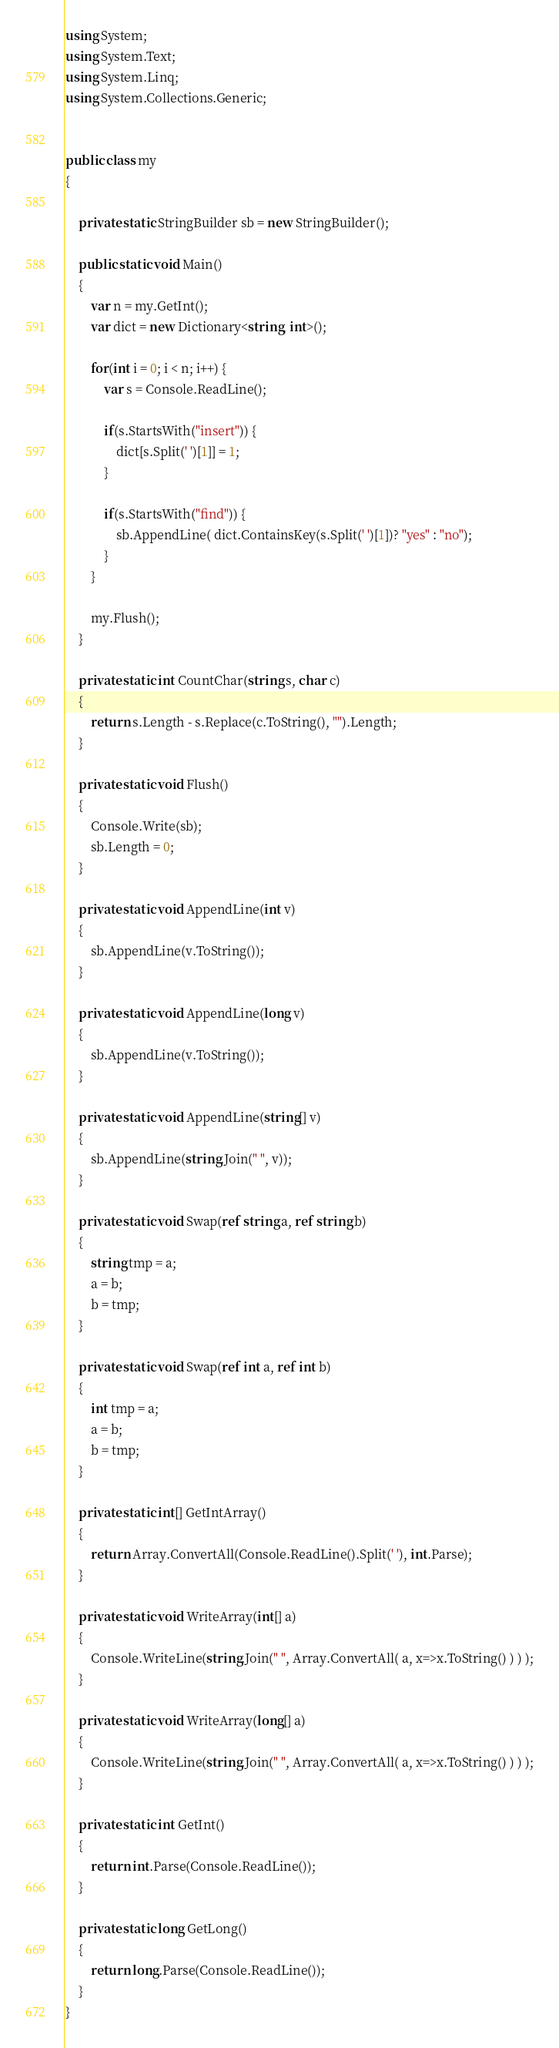<code> <loc_0><loc_0><loc_500><loc_500><_C#_>using System;
using System.Text;
using System.Linq;
using System.Collections.Generic;


public class my
{
	
	private static StringBuilder sb = new StringBuilder();
	
	public static void Main()
	{
		var n = my.GetInt();
		var dict = new Dictionary<string, int>();
		
		for(int i = 0; i < n; i++) {
			var s = Console.ReadLine();
			
			if(s.StartsWith("insert")) {
				dict[s.Split(' ')[1]] = 1;
			}
			
			if(s.StartsWith("find")) {
				sb.AppendLine( dict.ContainsKey(s.Split(' ')[1])? "yes" : "no");
			}
		}
		
		my.Flush();
	}
	
	private static int CountChar(string s, char c)
	{
		return s.Length - s.Replace(c.ToString(), "").Length;
	}
	
	private static void Flush()
	{
		Console.Write(sb);
		sb.Length = 0;
	}
	
	private static void AppendLine(int v)
	{
		sb.AppendLine(v.ToString());
	}
	
	private static void AppendLine(long v)
	{
		sb.AppendLine(v.ToString());
	}
	
	private static void AppendLine(string[] v)
	{
		sb.AppendLine(string.Join(" ", v));
	}

	private static void Swap(ref string a, ref string b) 
	{
		string tmp = a;
		a = b;
		b = tmp;
	}
	
	private static void Swap(ref int a, ref int b) 
	{
		int tmp = a;
		a = b;
		b = tmp;
	}
	
	private static int[] GetIntArray()
	{
		return Array.ConvertAll(Console.ReadLine().Split(' '), int.Parse);
	}
	
	private static void WriteArray(int[] a)
	{
		Console.WriteLine(string.Join(" ", Array.ConvertAll( a, x=>x.ToString() ) ) );
	}
	
	private static void WriteArray(long[] a)
	{
		Console.WriteLine(string.Join(" ", Array.ConvertAll( a, x=>x.ToString() ) ) );
	}
	
	private static int GetInt()
	{
		return int.Parse(Console.ReadLine());
	}
	
	private static long GetLong()
	{
		return long.Parse(Console.ReadLine());
	}
}</code> 